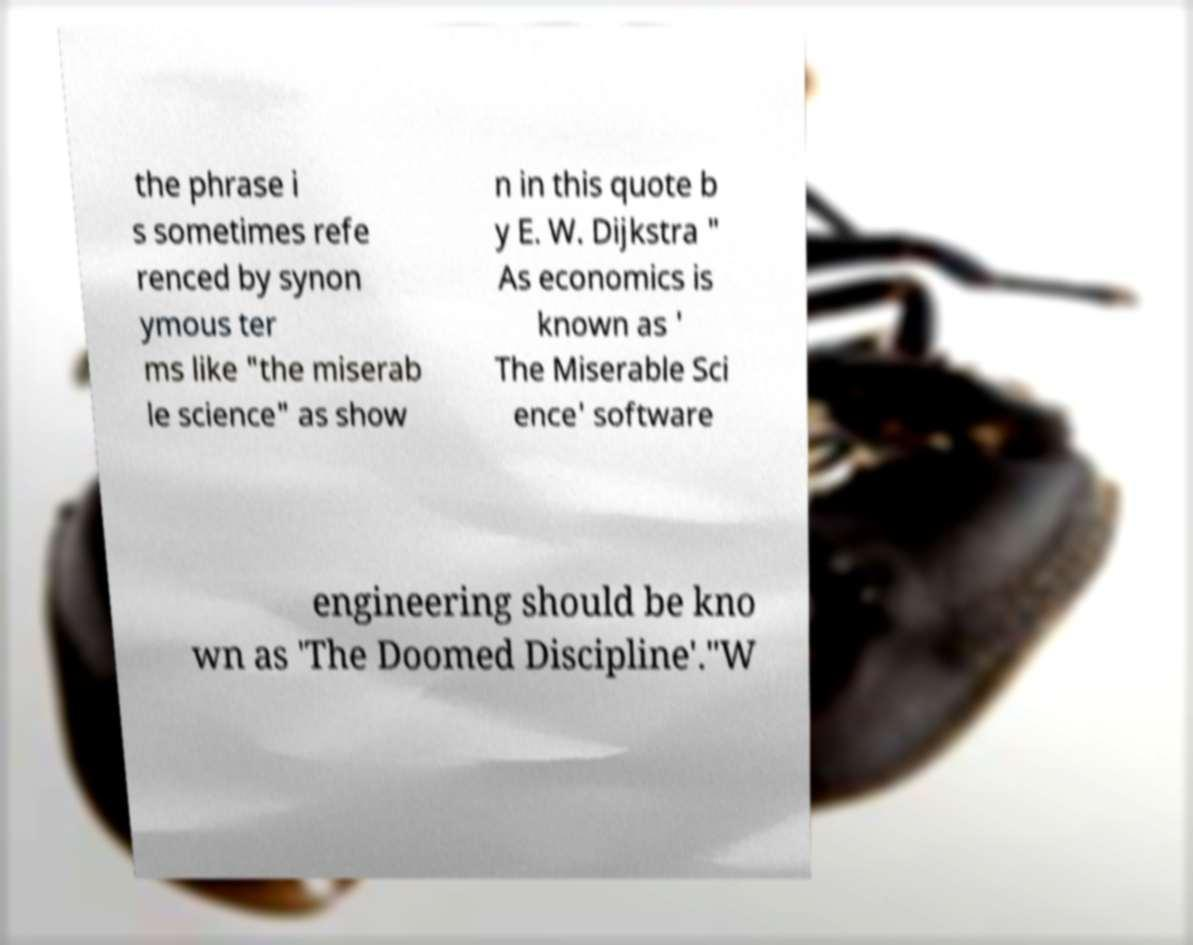I need the written content from this picture converted into text. Can you do that? the phrase i s sometimes refe renced by synon ymous ter ms like "the miserab le science" as show n in this quote b y E. W. Dijkstra " As economics is known as ' The Miserable Sci ence' software engineering should be kno wn as 'The Doomed Discipline'."W 